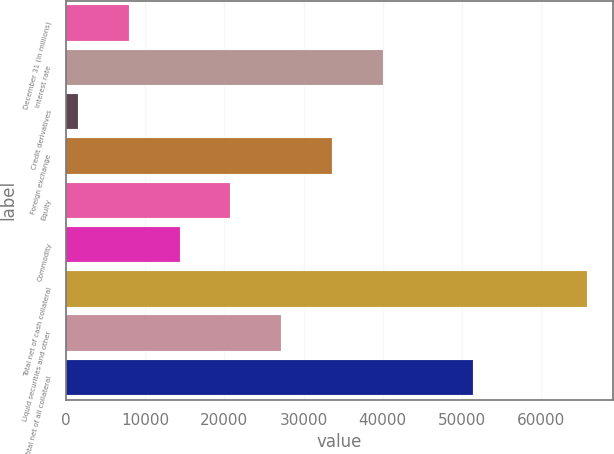<chart> <loc_0><loc_0><loc_500><loc_500><bar_chart><fcel>December 31 (in millions)<fcel>Interest rate<fcel>Credit derivatives<fcel>Foreign exchange<fcel>Equity<fcel>Commodity<fcel>Total net of cash collateral<fcel>Liquid securities and other<fcel>Total net of all collateral<nl><fcel>7940.3<fcel>40061.8<fcel>1516<fcel>33637.5<fcel>20788.9<fcel>14364.6<fcel>65759<fcel>27213.2<fcel>51324<nl></chart> 